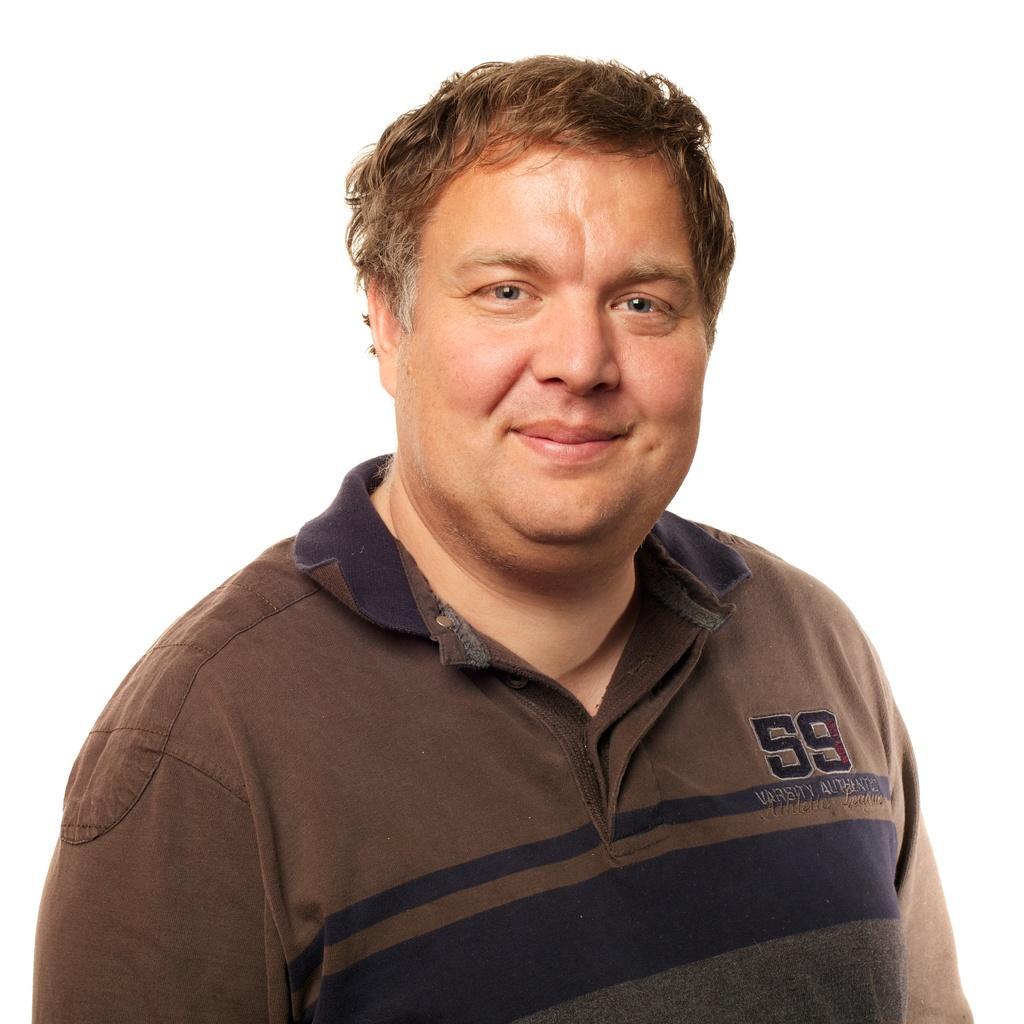Please provide a concise description of this image. In this picture, we see a man. He is wearing a brown T-shirt. He is smiling. In the background, it is white in color. 